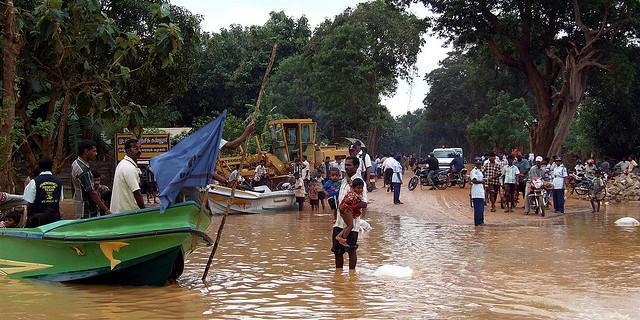How many people are there?
Give a very brief answer. 3. 